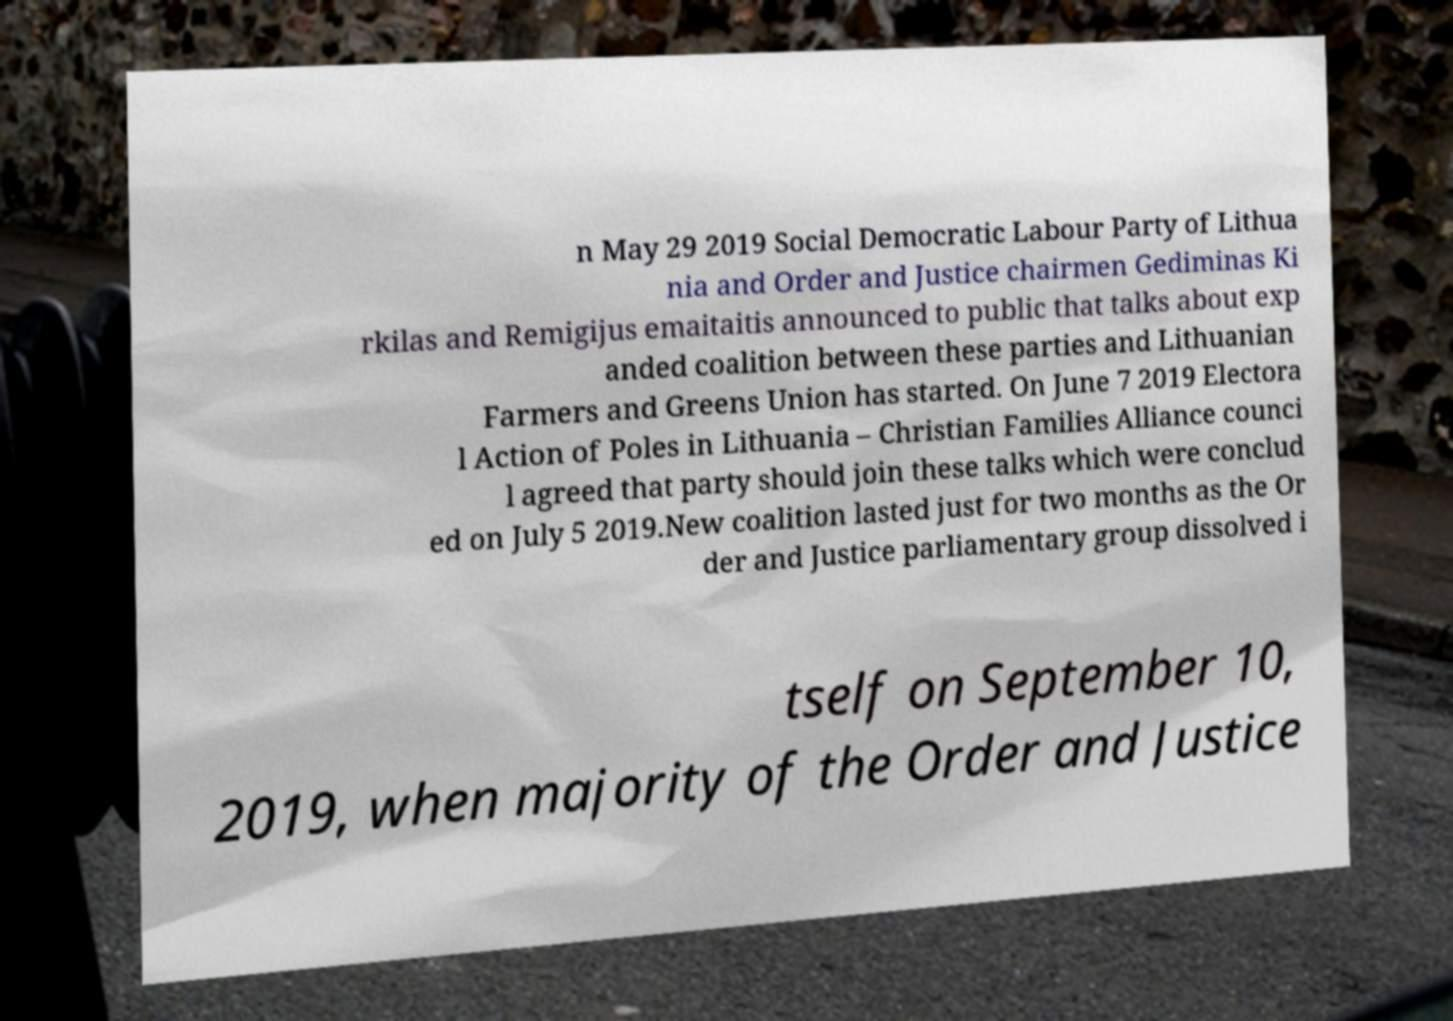There's text embedded in this image that I need extracted. Can you transcribe it verbatim? n May 29 2019 Social Democratic Labour Party of Lithua nia and Order and Justice chairmen Gediminas Ki rkilas and Remigijus emaitaitis announced to public that talks about exp anded coalition between these parties and Lithuanian Farmers and Greens Union has started. On June 7 2019 Electora l Action of Poles in Lithuania – Christian Families Alliance counci l agreed that party should join these talks which were conclud ed on July 5 2019.New coalition lasted just for two months as the Or der and Justice parliamentary group dissolved i tself on September 10, 2019, when majority of the Order and Justice 